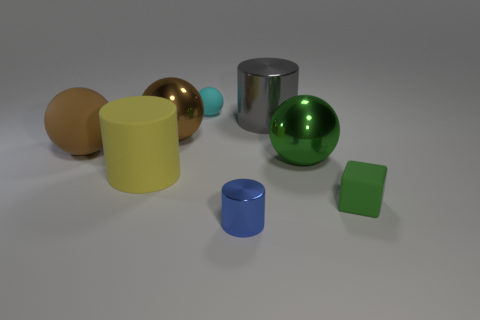There is another big thing that is the same shape as the large gray metallic thing; what material is it?
Offer a terse response. Rubber. There is a cylinder that is the same size as the gray metal thing; what is its color?
Offer a terse response. Yellow. Is the number of small cyan matte objects on the left side of the brown metallic sphere the same as the number of large gray balls?
Your answer should be very brief. Yes. What is the color of the large metallic ball that is left of the metal object in front of the rubber cylinder?
Provide a short and direct response. Brown. How big is the rubber ball that is in front of the metallic cylinder behind the small green object?
Your response must be concise. Large. There is a sphere that is the same color as the small cube; what size is it?
Offer a very short reply. Large. What number of other objects are the same size as the yellow cylinder?
Provide a short and direct response. 4. There is a large metal sphere on the right side of the object that is in front of the small thing right of the tiny blue metallic object; what color is it?
Your answer should be compact. Green. What number of other things are the same shape as the large yellow rubber object?
Offer a very short reply. 2. There is a small thing that is behind the matte block; what is its shape?
Provide a short and direct response. Sphere. 